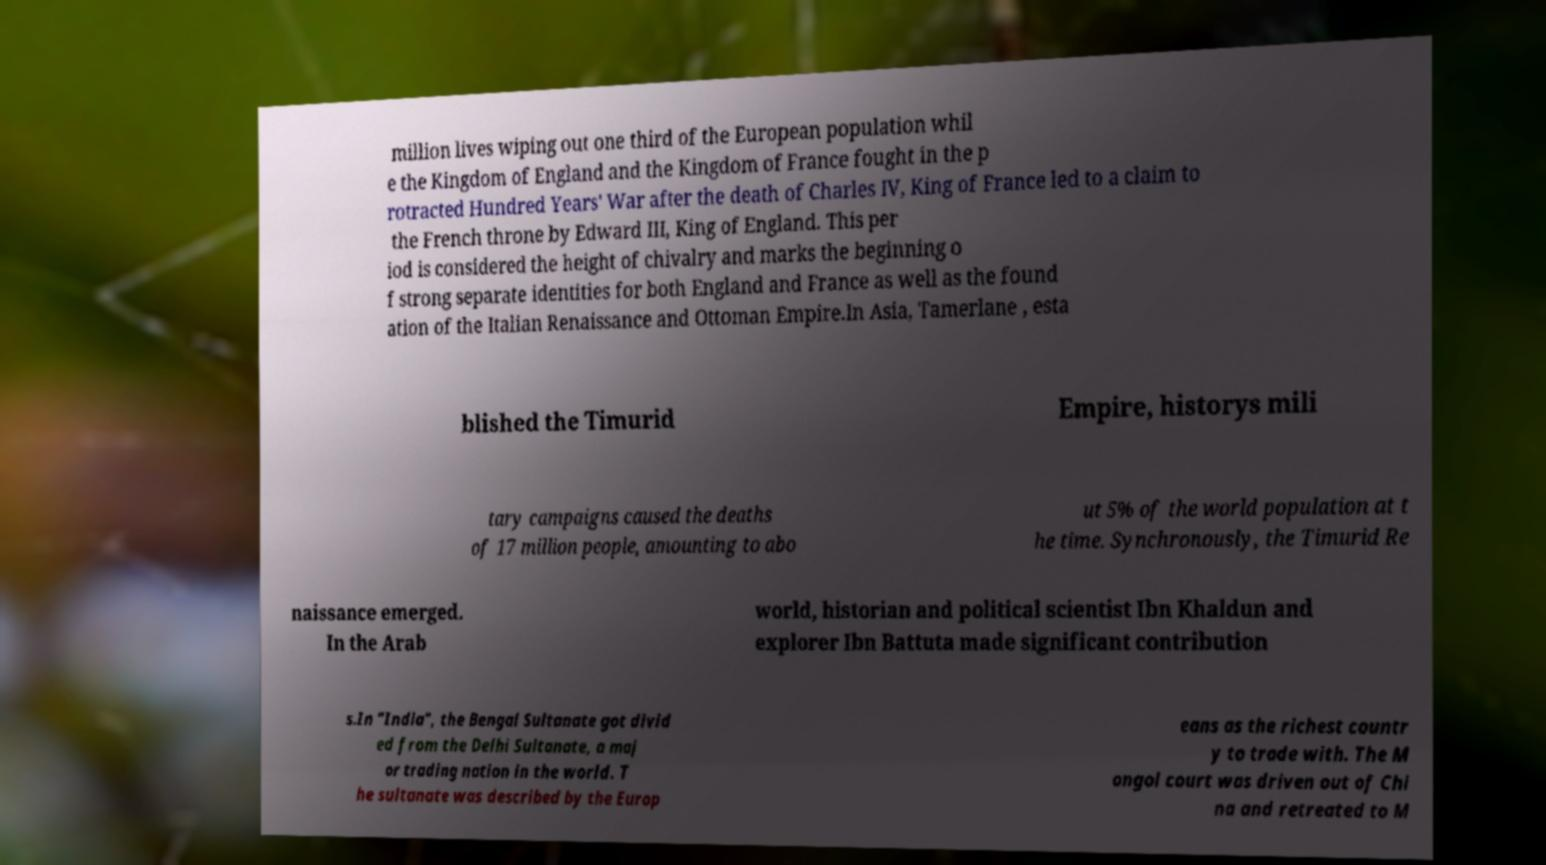What messages or text are displayed in this image? I need them in a readable, typed format. million lives wiping out one third of the European population whil e the Kingdom of England and the Kingdom of France fought in the p rotracted Hundred Years' War after the death of Charles IV, King of France led to a claim to the French throne by Edward III, King of England. This per iod is considered the height of chivalry and marks the beginning o f strong separate identities for both England and France as well as the found ation of the Italian Renaissance and Ottoman Empire.In Asia, Tamerlane , esta blished the Timurid Empire, historys mili tary campaigns caused the deaths of 17 million people, amounting to abo ut 5% of the world population at t he time. Synchronously, the Timurid Re naissance emerged. In the Arab world, historian and political scientist Ibn Khaldun and explorer Ibn Battuta made significant contribution s.In "India", the Bengal Sultanate got divid ed from the Delhi Sultanate, a maj or trading nation in the world. T he sultanate was described by the Europ eans as the richest countr y to trade with. The M ongol court was driven out of Chi na and retreated to M 